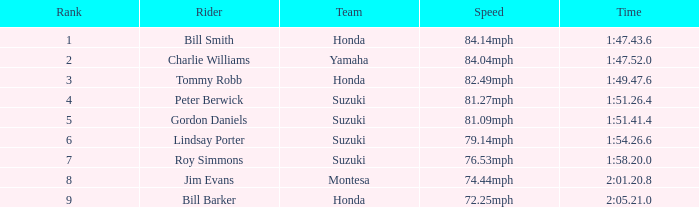Which rider had a time of 1:54.26.6? Lindsay Porter. 